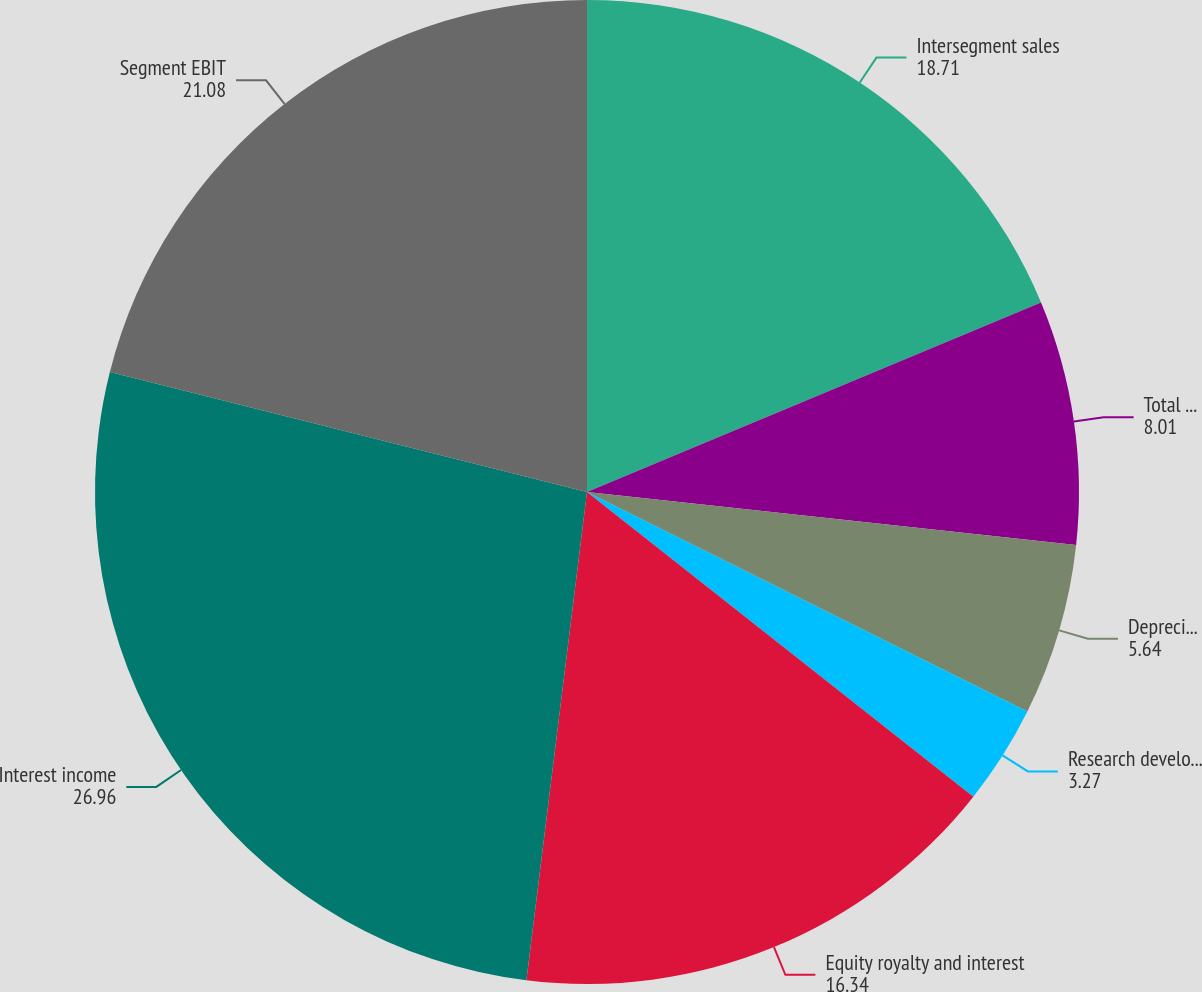<chart> <loc_0><loc_0><loc_500><loc_500><pie_chart><fcel>Intersegment sales<fcel>Total sales<fcel>Depreciation and amortization<fcel>Research development and<fcel>Equity royalty and interest<fcel>Interest income<fcel>Segment EBIT<nl><fcel>18.71%<fcel>8.01%<fcel>5.64%<fcel>3.27%<fcel>16.34%<fcel>26.96%<fcel>21.08%<nl></chart> 